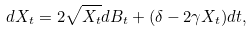Convert formula to latex. <formula><loc_0><loc_0><loc_500><loc_500>d X _ { t } = 2 \sqrt { X _ { t } } d B _ { t } + ( \delta - 2 \gamma X _ { t } ) d t ,</formula> 